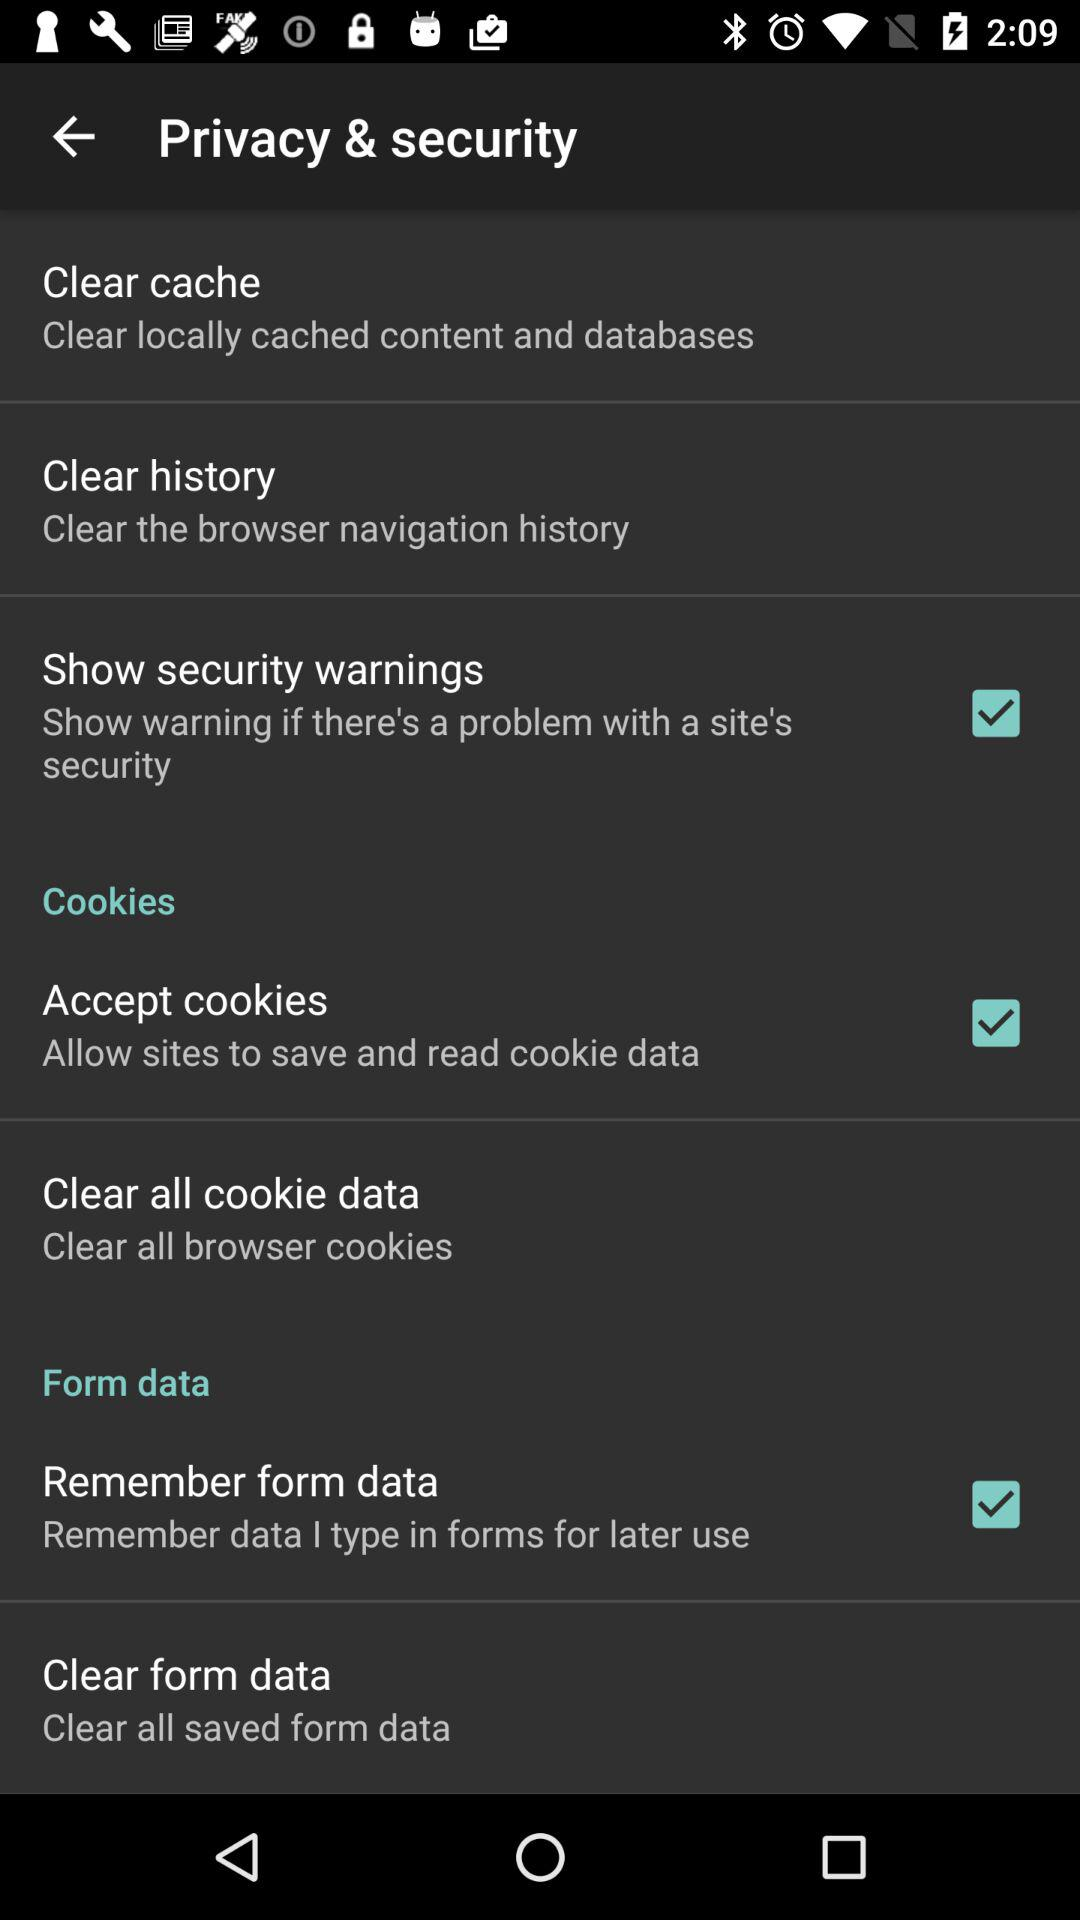What's the status of "Accept cookies"? The status of "Accept cookies" is "on". 